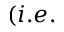<formula> <loc_0><loc_0><loc_500><loc_500>( i . e .</formula> 